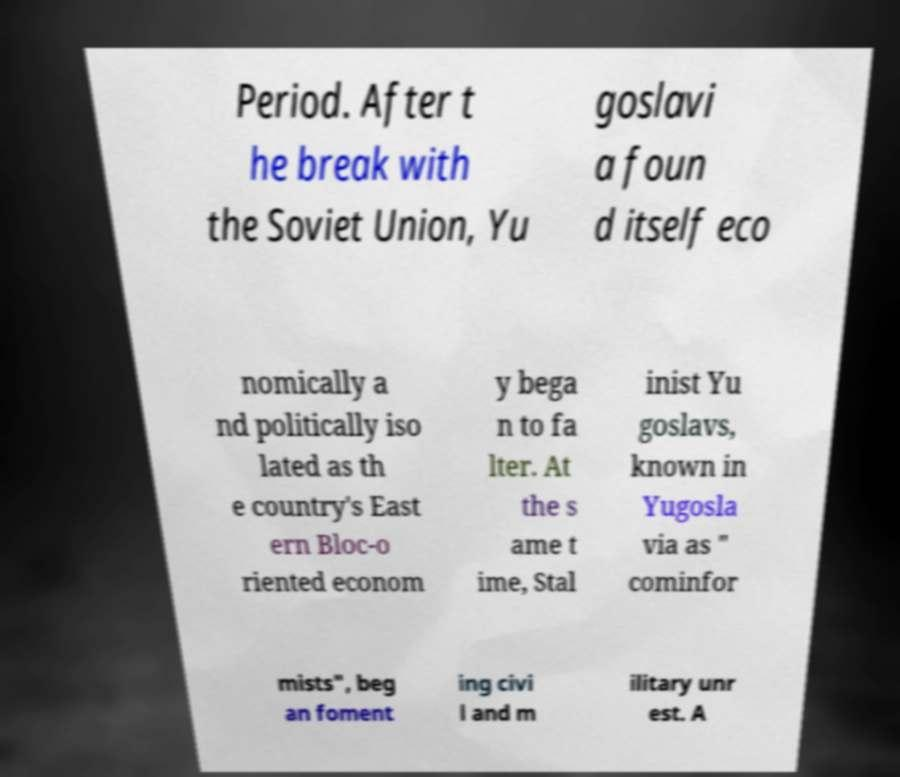There's text embedded in this image that I need extracted. Can you transcribe it verbatim? Period. After t he break with the Soviet Union, Yu goslavi a foun d itself eco nomically a nd politically iso lated as th e country's East ern Bloc-o riented econom y bega n to fa lter. At the s ame t ime, Stal inist Yu goslavs, known in Yugosla via as " cominfor mists", beg an foment ing civi l and m ilitary unr est. A 